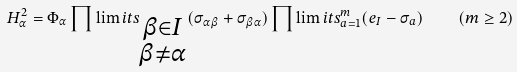<formula> <loc_0><loc_0><loc_500><loc_500>H _ { \alpha } ^ { 2 } = \Phi _ { \alpha } \prod \lim i t s _ { \substack { \beta \in I \\ \beta \neq \alpha } } ( \sigma _ { \alpha \beta } + \sigma _ { \beta \alpha } ) \prod \lim i t s _ { a = 1 } ^ { m } ( e _ { I } - \sigma _ { a } ) \quad ( m \geq 2 )</formula> 